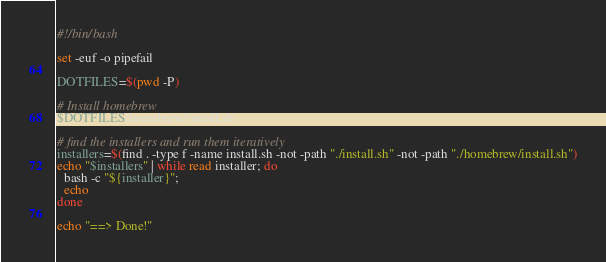Convert code to text. <code><loc_0><loc_0><loc_500><loc_500><_Bash_>#!/bin/bash

set -euf -o pipefail

DOTFILES=$(pwd -P)

# Install homebrew
$DOTFILES/homebrew/install.sh

# find the installers and run them iteratively
installers=$(find . -type f -name install.sh -not -path "./install.sh" -not -path "./homebrew/install.sh")
echo "$installers" | while read installer; do
  bash -c "${installer}";
  echo
done

echo "==> Done!"
</code> 